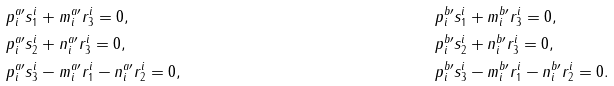Convert formula to latex. <formula><loc_0><loc_0><loc_500><loc_500>& p ^ { a \prime } _ { i } s _ { 1 } ^ { i } + { m ^ { a \prime } _ { i } } r _ { 3 } ^ { i } = 0 , & & p ^ { b \prime } _ { i } s _ { 1 } ^ { i } + { m ^ { b \prime } _ { i } } r _ { 3 } ^ { i } = 0 , \\ & p ^ { a \prime } _ { i } s _ { 2 } ^ { i } + { n ^ { a \prime } _ { i } } r _ { 3 } ^ { i } = 0 , & & p ^ { b \prime } _ { i } s _ { 2 } ^ { i } + { n ^ { b \prime } _ { i } } r _ { 3 } ^ { i } = 0 , \\ & p ^ { a \prime } _ { i } s _ { 3 } ^ { i } - { m ^ { a \prime } _ { i } } r _ { 1 } ^ { i } - { n ^ { a \prime } _ { i } } r _ { 2 } ^ { i } = 0 , & & p ^ { b \prime } _ { i } s _ { 3 } ^ { i } - { m ^ { b \prime } _ { i } } r _ { 1 } ^ { i } - { n ^ { b \prime } _ { i } } r _ { 2 } ^ { i } = 0 .</formula> 